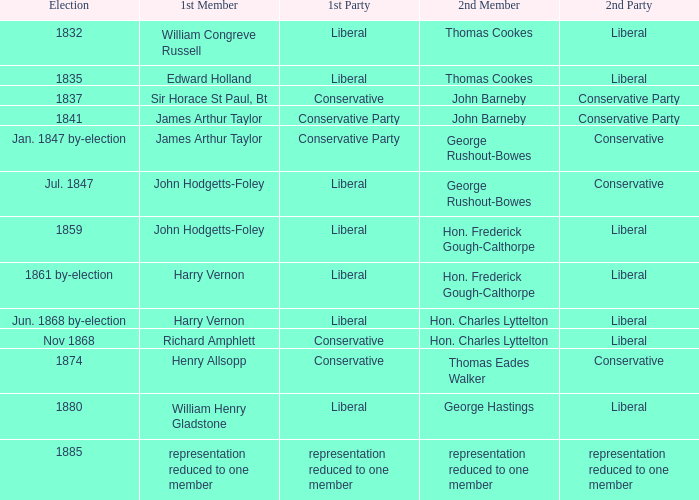Can you parse all the data within this table? {'header': ['Election', '1st Member', '1st Party', '2nd Member', '2nd Party'], 'rows': [['1832', 'William Congreve Russell', 'Liberal', 'Thomas Cookes', 'Liberal'], ['1835', 'Edward Holland', 'Liberal', 'Thomas Cookes', 'Liberal'], ['1837', 'Sir Horace St Paul, Bt', 'Conservative', 'John Barneby', 'Conservative Party'], ['1841', 'James Arthur Taylor', 'Conservative Party', 'John Barneby', 'Conservative Party'], ['Jan. 1847 by-election', 'James Arthur Taylor', 'Conservative Party', 'George Rushout-Bowes', 'Conservative'], ['Jul. 1847', 'John Hodgetts-Foley', 'Liberal', 'George Rushout-Bowes', 'Conservative'], ['1859', 'John Hodgetts-Foley', 'Liberal', 'Hon. Frederick Gough-Calthorpe', 'Liberal'], ['1861 by-election', 'Harry Vernon', 'Liberal', 'Hon. Frederick Gough-Calthorpe', 'Liberal'], ['Jun. 1868 by-election', 'Harry Vernon', 'Liberal', 'Hon. Charles Lyttelton', 'Liberal'], ['Nov 1868', 'Richard Amphlett', 'Conservative', 'Hon. Charles Lyttelton', 'Liberal'], ['1874', 'Henry Allsopp', 'Conservative', 'Thomas Eades Walker', 'Conservative'], ['1880', 'William Henry Gladstone', 'Liberal', 'George Hastings', 'Liberal'], ['1885', 'representation reduced to one member', 'representation reduced to one member', 'representation reduced to one member', 'representation reduced to one member']]} What was the following party that had the second member john barneby, when the preceding party was conservative? Conservative Party. 